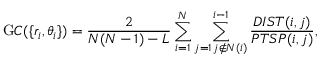<formula> <loc_0><loc_0><loc_500><loc_500>{ \mathrm G C } ( \{ r _ { i } , \theta _ { i } \} ) = \frac { 2 } { N ( N - 1 ) - L } \sum _ { i = 1 } ^ { N } \sum _ { \substack { j = 1 \, j \notin N ( i ) } } ^ { i - 1 } \frac { D I S T ( i , j ) } { P T S P ( i , j ) } ,</formula> 